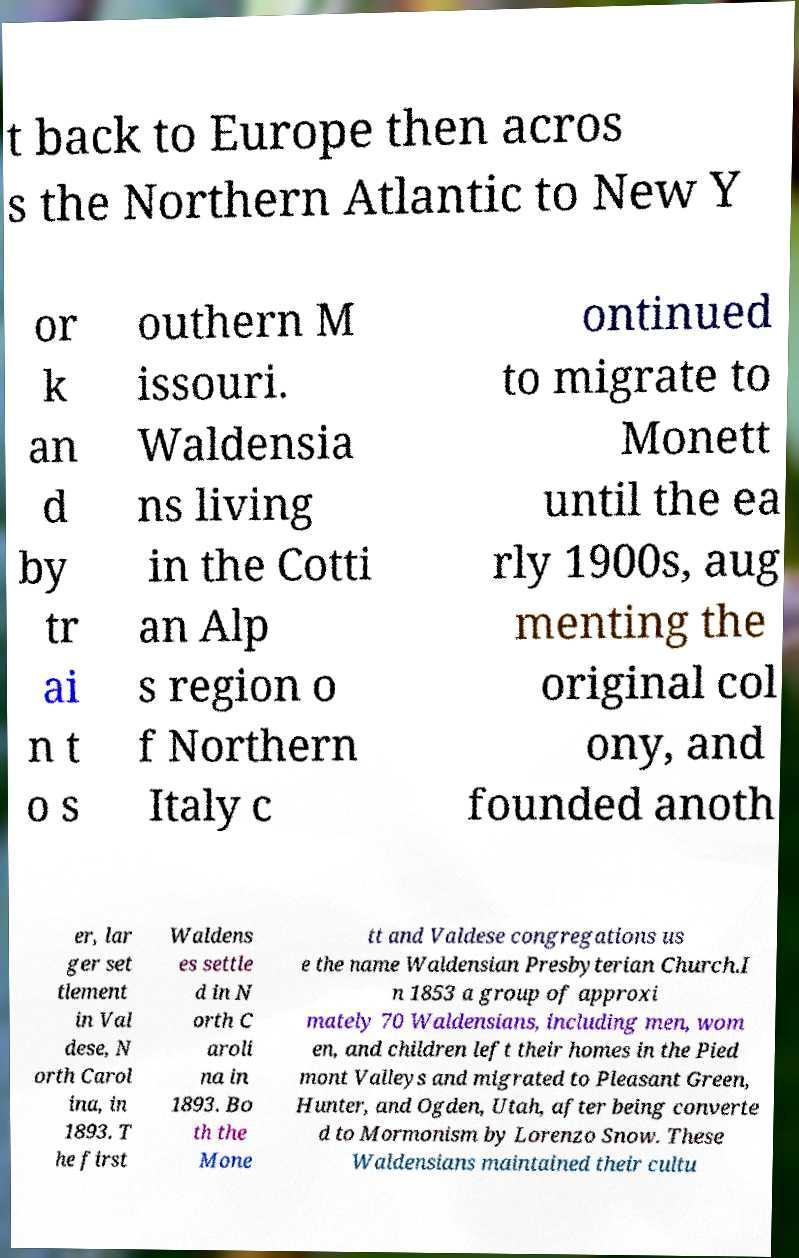I need the written content from this picture converted into text. Can you do that? t back to Europe then acros s the Northern Atlantic to New Y or k an d by tr ai n t o s outhern M issouri. Waldensia ns living in the Cotti an Alp s region o f Northern Italy c ontinued to migrate to Monett until the ea rly 1900s, aug menting the original col ony, and founded anoth er, lar ger set tlement in Val dese, N orth Carol ina, in 1893. T he first Waldens es settle d in N orth C aroli na in 1893. Bo th the Mone tt and Valdese congregations us e the name Waldensian Presbyterian Church.I n 1853 a group of approxi mately 70 Waldensians, including men, wom en, and children left their homes in the Pied mont Valleys and migrated to Pleasant Green, Hunter, and Ogden, Utah, after being converte d to Mormonism by Lorenzo Snow. These Waldensians maintained their cultu 